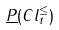<formula> <loc_0><loc_0><loc_500><loc_500>\underline { P } ( C l _ { t } ^ { \leq } )</formula> 